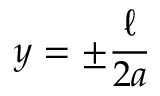Convert formula to latex. <formula><loc_0><loc_0><loc_500><loc_500>y = \pm \frac { \ell } { 2 a }</formula> 